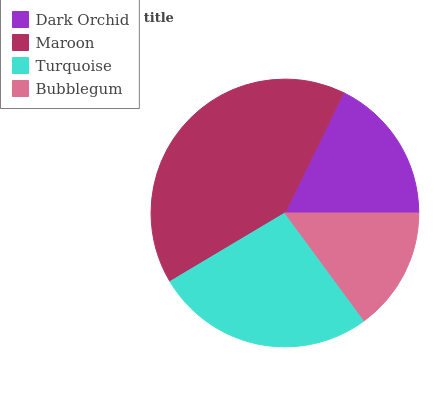Is Bubblegum the minimum?
Answer yes or no. Yes. Is Maroon the maximum?
Answer yes or no. Yes. Is Turquoise the minimum?
Answer yes or no. No. Is Turquoise the maximum?
Answer yes or no. No. Is Maroon greater than Turquoise?
Answer yes or no. Yes. Is Turquoise less than Maroon?
Answer yes or no. Yes. Is Turquoise greater than Maroon?
Answer yes or no. No. Is Maroon less than Turquoise?
Answer yes or no. No. Is Turquoise the high median?
Answer yes or no. Yes. Is Dark Orchid the low median?
Answer yes or no. Yes. Is Dark Orchid the high median?
Answer yes or no. No. Is Maroon the low median?
Answer yes or no. No. 